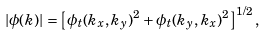<formula> <loc_0><loc_0><loc_500><loc_500>| \phi ( { k } ) | = \left [ \phi _ { t } ( k _ { x } , k _ { y } ) ^ { 2 } + \phi _ { t } ( k _ { y } , k _ { x } ) ^ { 2 } \right ] ^ { 1 / 2 } ,</formula> 